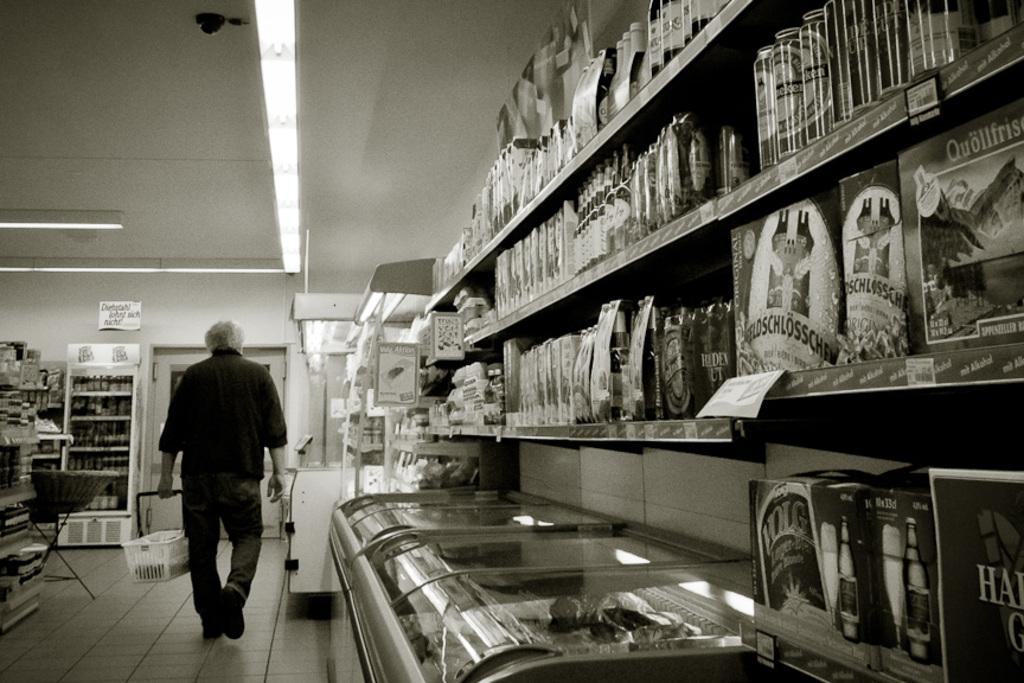What is the person in the image doing? The person is standing in the image and holding a shopping cart. What items can be seen in the shopping cart? The provided facts do not specify the contents of the shopping cart. What type of items are present in the image besides the person and shopping cart? There are bottles, boxes, and objects in the racks and refrigerator visible in the image. What can be seen in the background of the image? There are lights, a door, and a wall in the image. What type of cast can be seen on the person's arm in the image? There is no cast visible on the person's arm in the image. What type of yard is visible through the door in the image? There is: There is no yard visible through the door in the image; it leads to another area within the same building. 